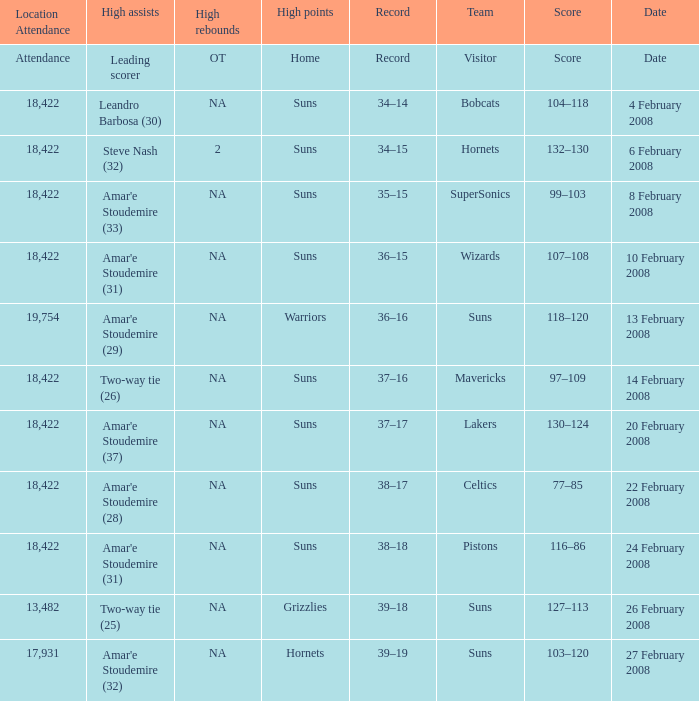How many high assists did the Lakers have? Amar'e Stoudemire (37). 